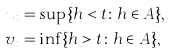<formula> <loc_0><loc_0><loc_500><loc_500>u _ { t } & = \sup \{ h < t \colon h \in A \} , \\ v _ { t } & = \inf \{ h > t \colon h \in A \} ,</formula> 